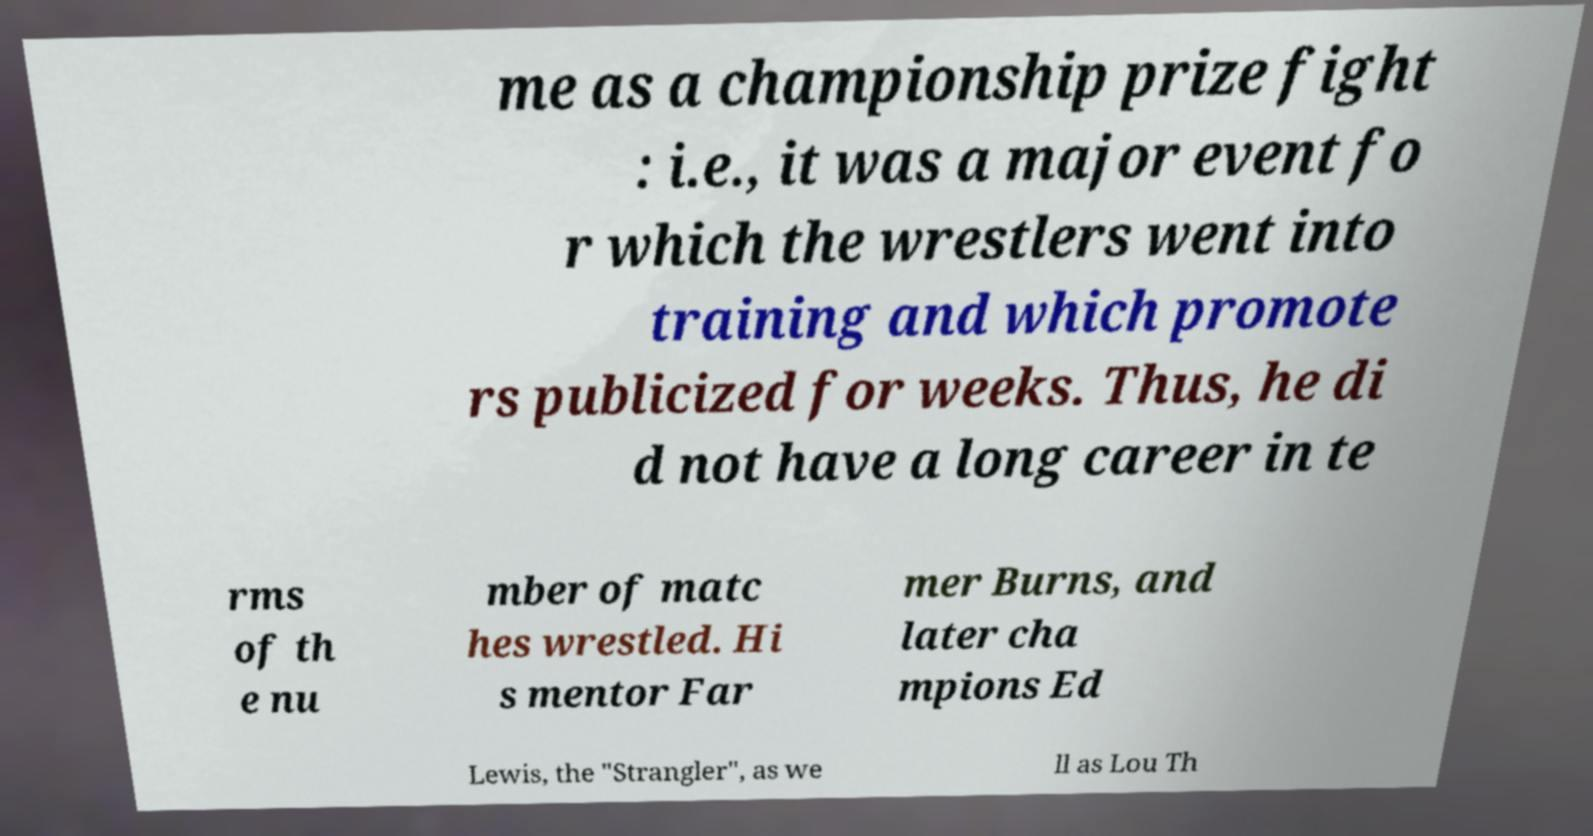Please identify and transcribe the text found in this image. me as a championship prize fight : i.e., it was a major event fo r which the wrestlers went into training and which promote rs publicized for weeks. Thus, he di d not have a long career in te rms of th e nu mber of matc hes wrestled. Hi s mentor Far mer Burns, and later cha mpions Ed Lewis, the "Strangler", as we ll as Lou Th 